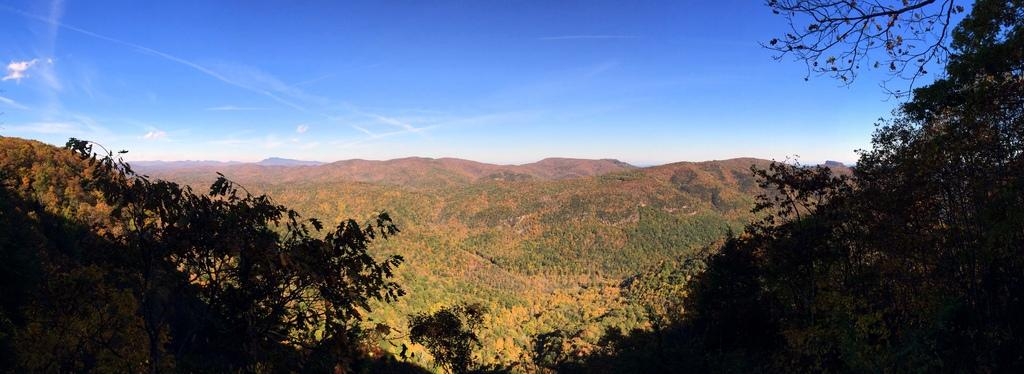What is the location of the image in relation to the city? The image is taken from outside of the city. What type of vegetation can be seen in the image? There are trees in the image. What other natural elements are present in the image? There are rocks and mountains in the image. What is visible at the top of the image? The sky is visible at the top of the image. What is the average income of the trees in the image? Trees do not have an income, so this question cannot be answered. 